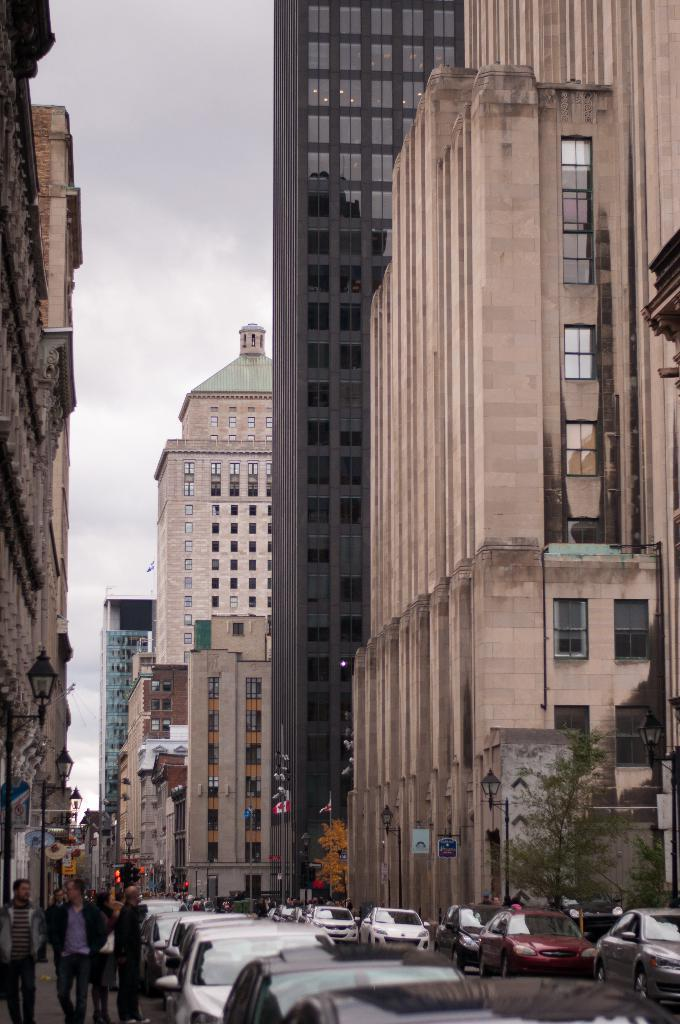What type of structures can be seen in the image? There are buildings in the image. What else is present in the image besides buildings? There are vehicles and people beside the vehicles in the image. What can be seen in front of the buildings? There are trees in front of the buildings. What is visible in the background of the image? The sky is visible in the background of the image. What type of mint is growing beside the vehicles in the image? There is no mint visible in the image; it features trees beside the vehicles. What is the voice of the person standing beside the vehicle in the image? There is no voice mentioned in the image, as it only provides visual information. 